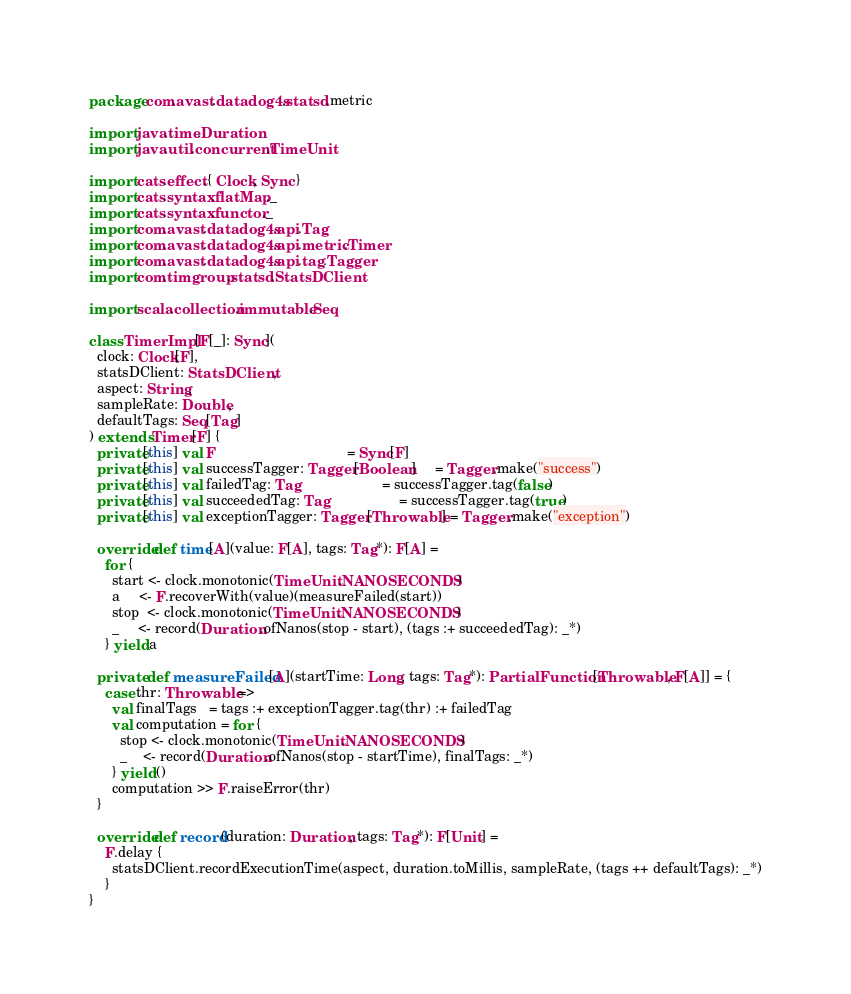<code> <loc_0><loc_0><loc_500><loc_500><_Scala_>package com.avast.datadog4s.statsd.metric

import java.time.Duration
import java.util.concurrent.TimeUnit

import cats.effect.{ Clock, Sync }
import cats.syntax.flatMap._
import cats.syntax.functor._
import com.avast.datadog4s.api.Tag
import com.avast.datadog4s.api.metric.Timer
import com.avast.datadog4s.api.tag.Tagger
import com.timgroup.statsd.StatsDClient

import scala.collection.immutable.Seq

class TimerImpl[F[_]: Sync](
  clock: Clock[F],
  statsDClient: StatsDClient,
  aspect: String,
  sampleRate: Double,
  defaultTags: Seq[Tag]
) extends Timer[F] {
  private[this] val F                                  = Sync[F]
  private[this] val successTagger: Tagger[Boolean]     = Tagger.make("success")
  private[this] val failedTag: Tag                     = successTagger.tag(false)
  private[this] val succeededTag: Tag                  = successTagger.tag(true)
  private[this] val exceptionTagger: Tagger[Throwable] = Tagger.make("exception")

  override def time[A](value: F[A], tags: Tag*): F[A] =
    for {
      start <- clock.monotonic(TimeUnit.NANOSECONDS)
      a     <- F.recoverWith(value)(measureFailed(start))
      stop  <- clock.monotonic(TimeUnit.NANOSECONDS)
      _     <- record(Duration.ofNanos(stop - start), (tags :+ succeededTag): _*)
    } yield a

  private def measureFailed[A](startTime: Long, tags: Tag*): PartialFunction[Throwable, F[A]] = {
    case thr: Throwable =>
      val finalTags   = tags :+ exceptionTagger.tag(thr) :+ failedTag
      val computation = for {
        stop <- clock.monotonic(TimeUnit.NANOSECONDS)
        _    <- record(Duration.ofNanos(stop - startTime), finalTags: _*)
      } yield ()
      computation >> F.raiseError(thr)
  }

  override def record(duration: Duration, tags: Tag*): F[Unit] =
    F.delay {
      statsDClient.recordExecutionTime(aspect, duration.toMillis, sampleRate, (tags ++ defaultTags): _*)
    }
}
</code> 